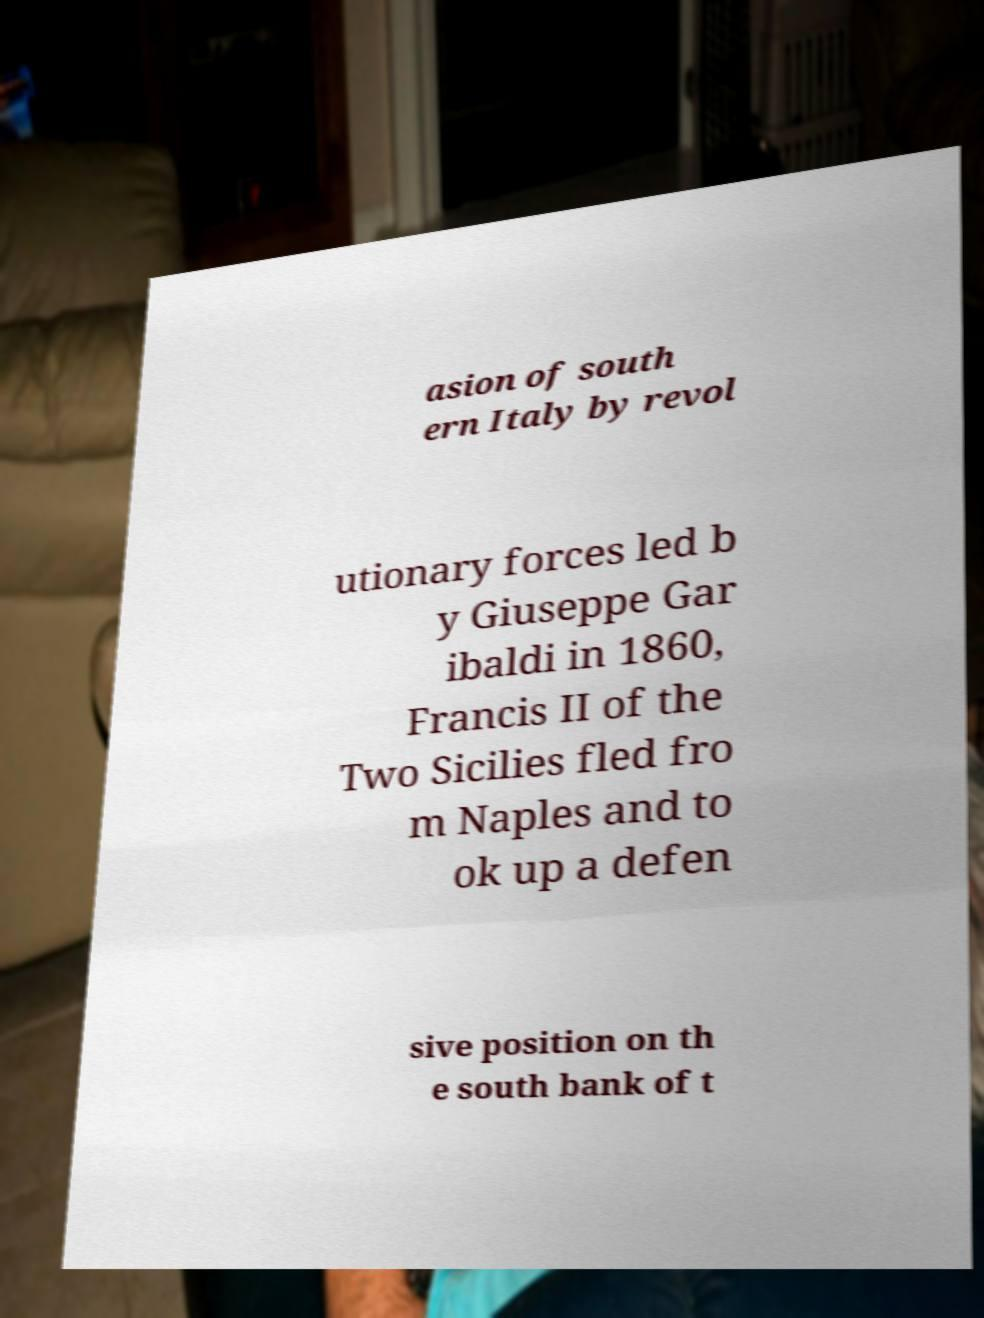Could you extract and type out the text from this image? asion of south ern Italy by revol utionary forces led b y Giuseppe Gar ibaldi in 1860, Francis II of the Two Sicilies fled fro m Naples and to ok up a defen sive position on th e south bank of t 